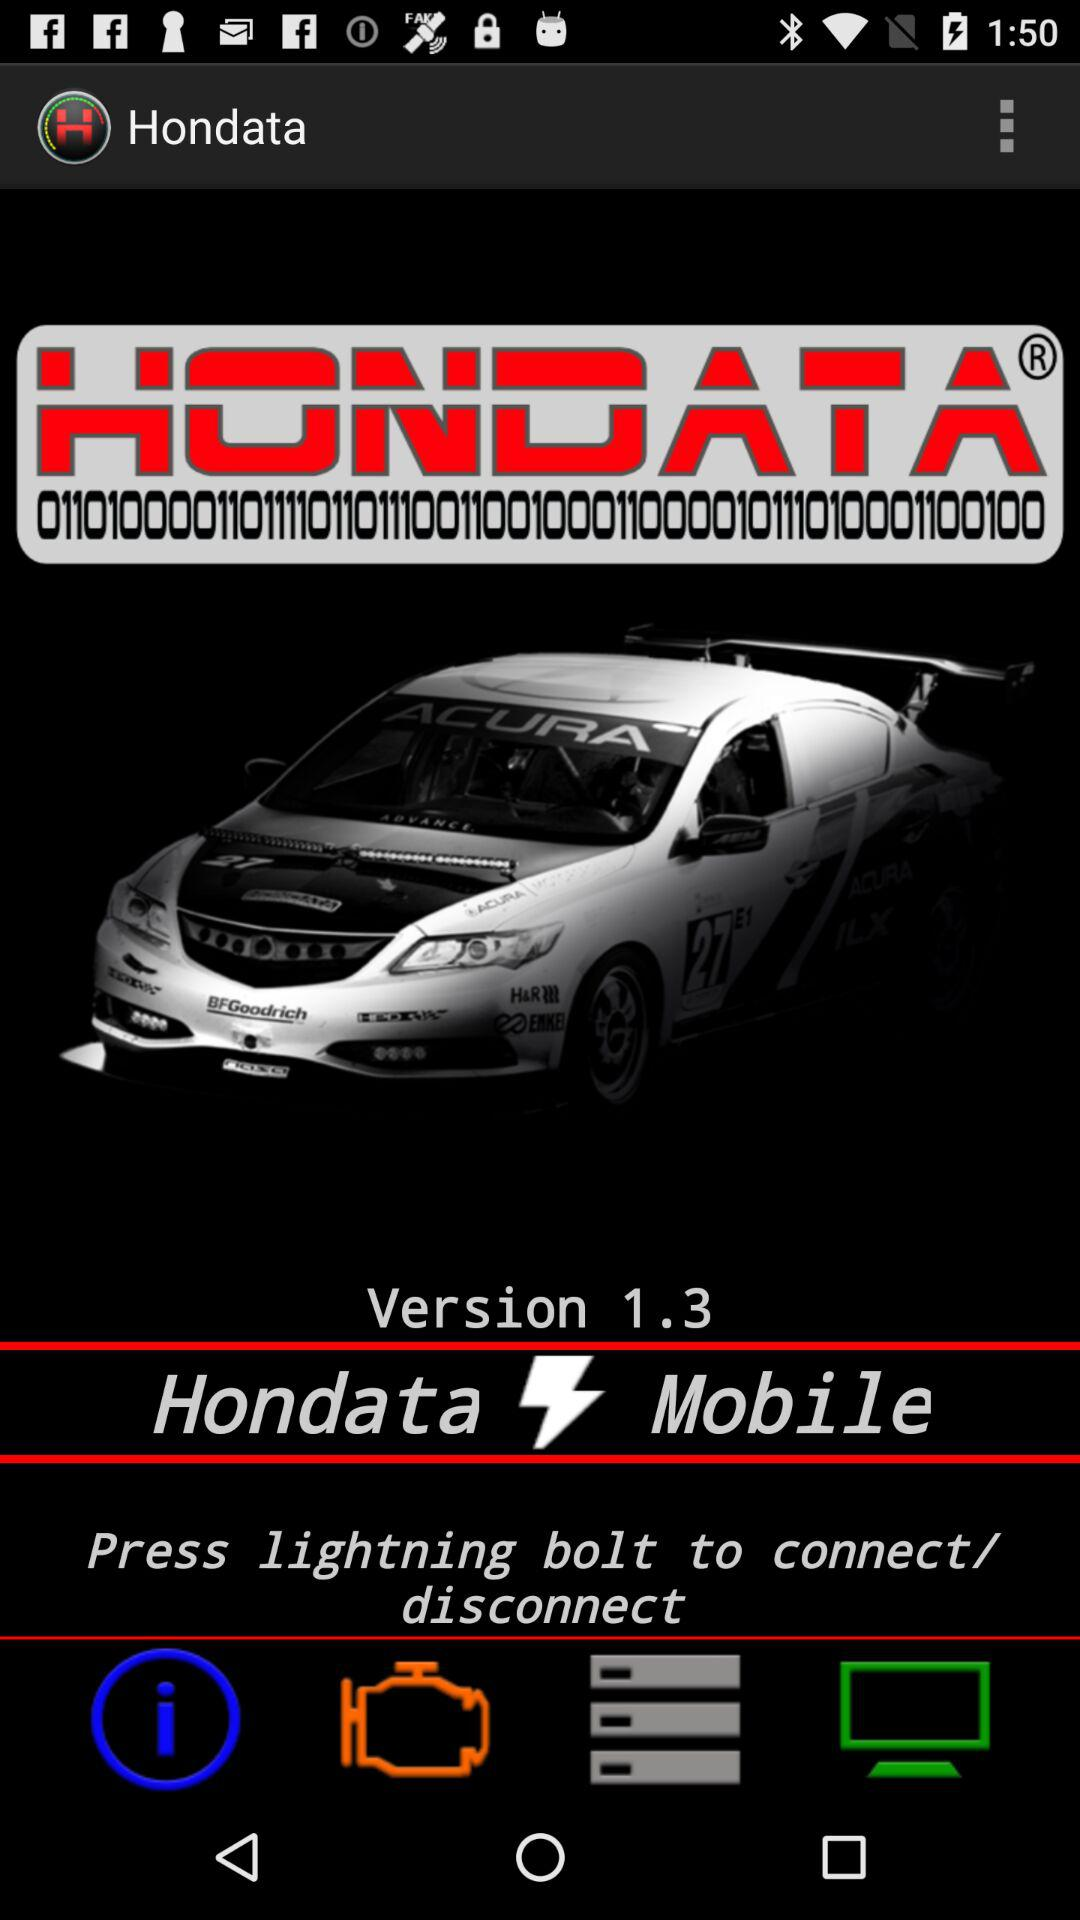What bolt should be pressed to connect or disconnect? To connect or disconnect, the lightning bolt should be pressed. 